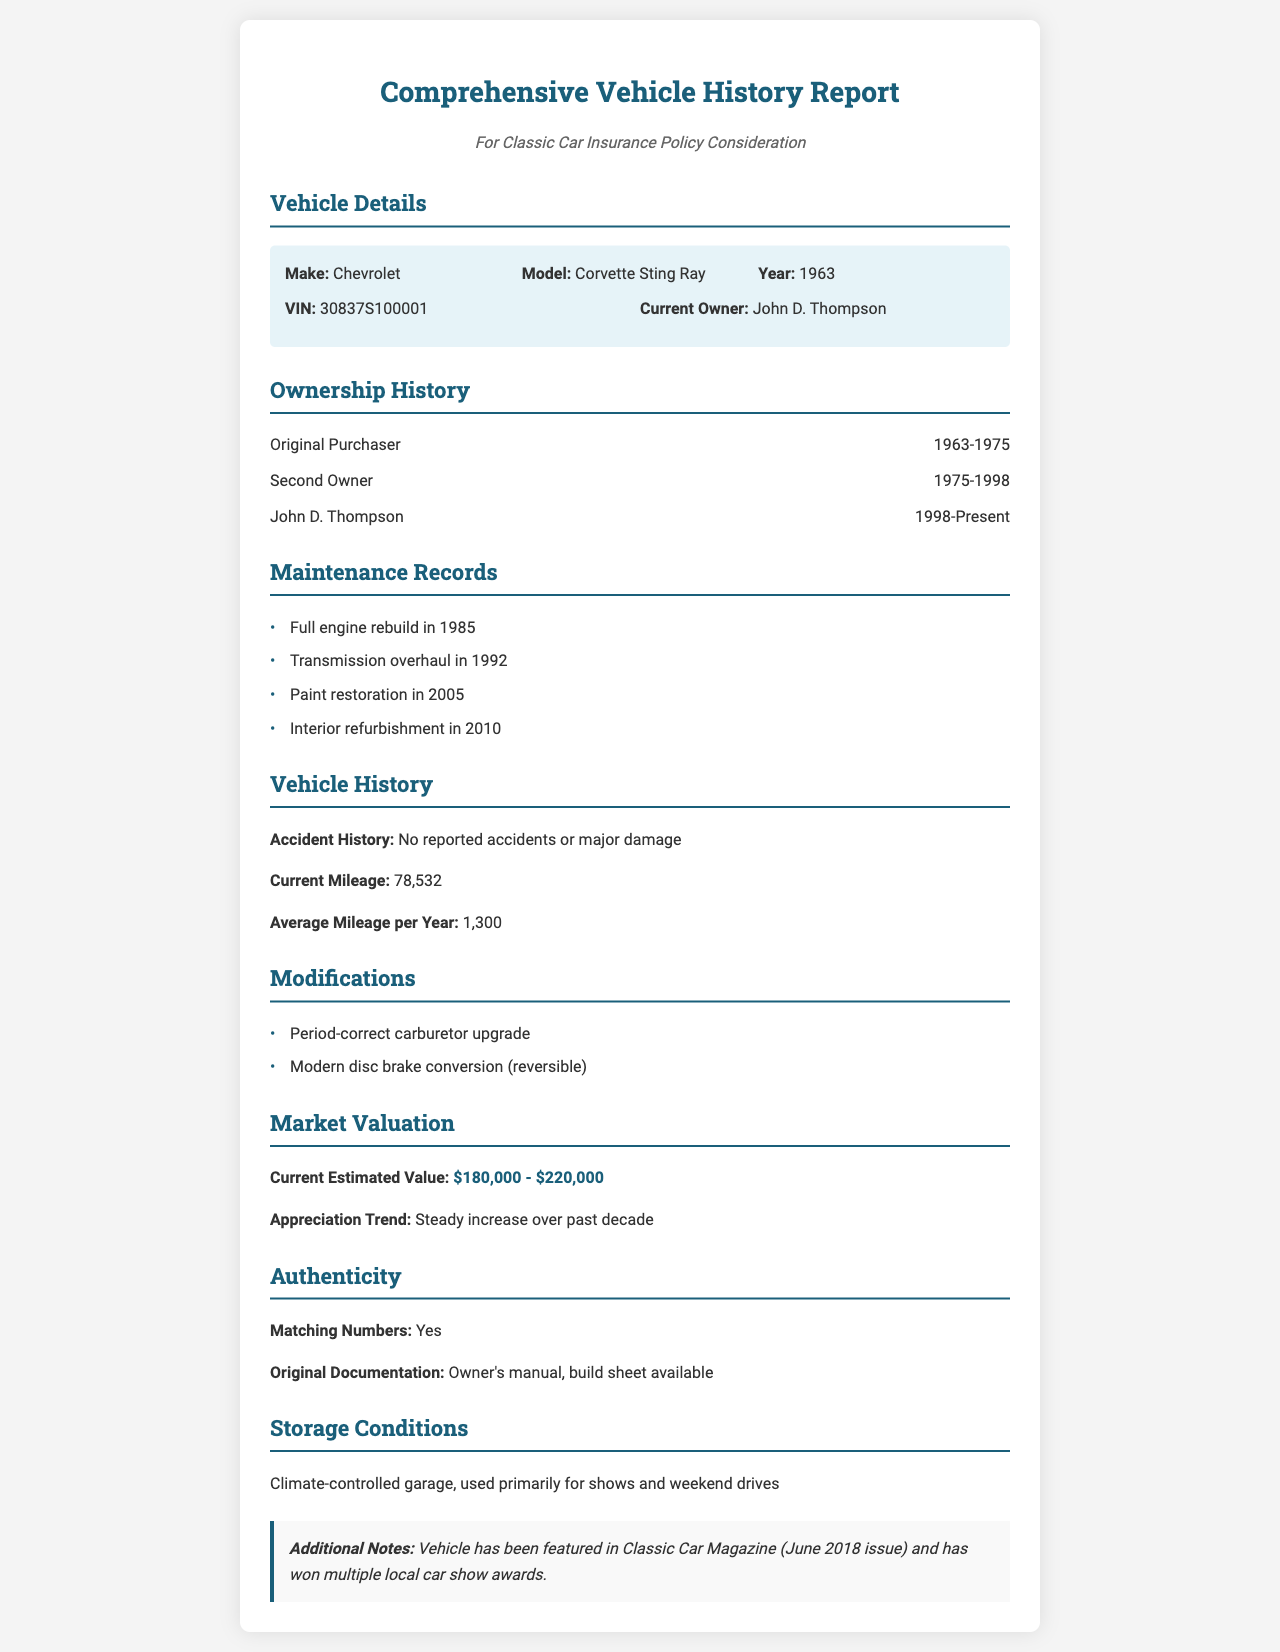What is the make of the vehicle? The make of the vehicle is provided in the vehicle details section of the document.
Answer: Chevrolet What is the model of the vehicle? The model is mentioned right next to the make in the vehicle details section.
Answer: Corvette Sting Ray Who is the current owner of the vehicle? The current owner's name is listed in the vehicle details section.
Answer: John D. Thompson What was the accident history of the vehicle? The document explicitly states the accident history in the vehicle history section.
Answer: No reported accidents or major damage What year did the original purchaser own the vehicle? The ownership timeline for the original purchaser can be found in the ownership history section.
Answer: 1963-1975 What is the current mileage of the vehicle? Current mileage is stated in the vehicle history section.
Answer: 78,532 What is the current estimated value range of the vehicle? The estimated value range is given in the market valuation section.
Answer: $180,000 - $220,000 What modifications were made to the vehicle? The modifications are listed in the modifications section of the document.
Answer: Period-correct carburetor upgrade, Modern disc brake conversion (reversible) In which magazine was the vehicle featured? The document mentions the magazine in the additional notes section.
Answer: Classic Car Magazine What condition is the vehicle stored in? The storage conditions are outlined in the storage conditions section.
Answer: Climate-controlled garage, used primarily for shows and weekend drives 